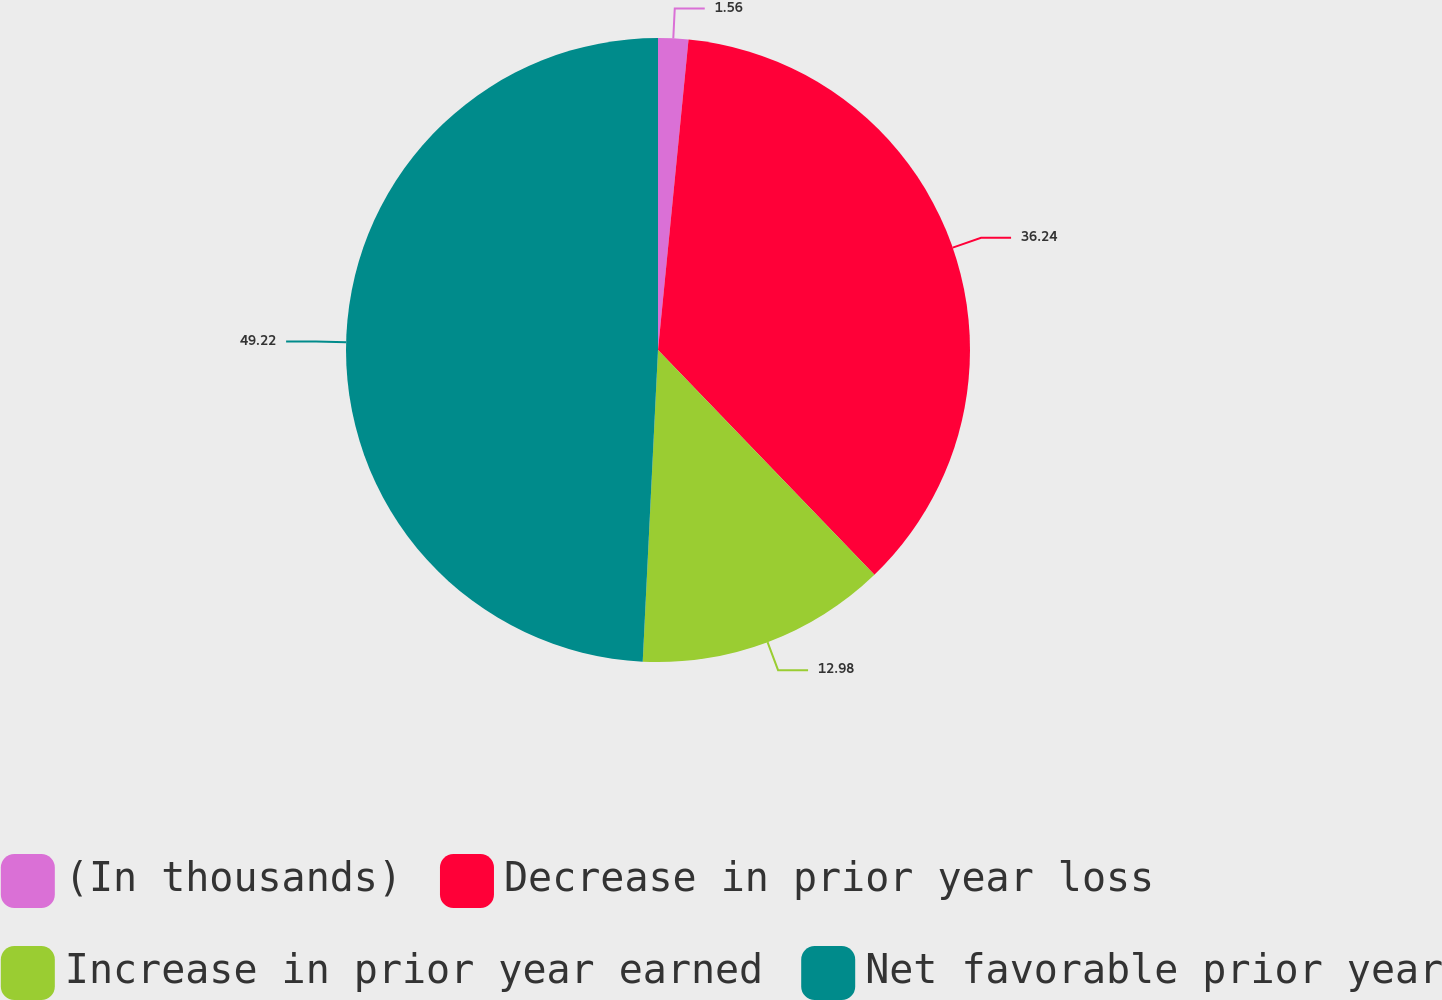Convert chart to OTSL. <chart><loc_0><loc_0><loc_500><loc_500><pie_chart><fcel>(In thousands)<fcel>Decrease in prior year loss<fcel>Increase in prior year earned<fcel>Net favorable prior year<nl><fcel>1.56%<fcel>36.24%<fcel>12.98%<fcel>49.22%<nl></chart> 